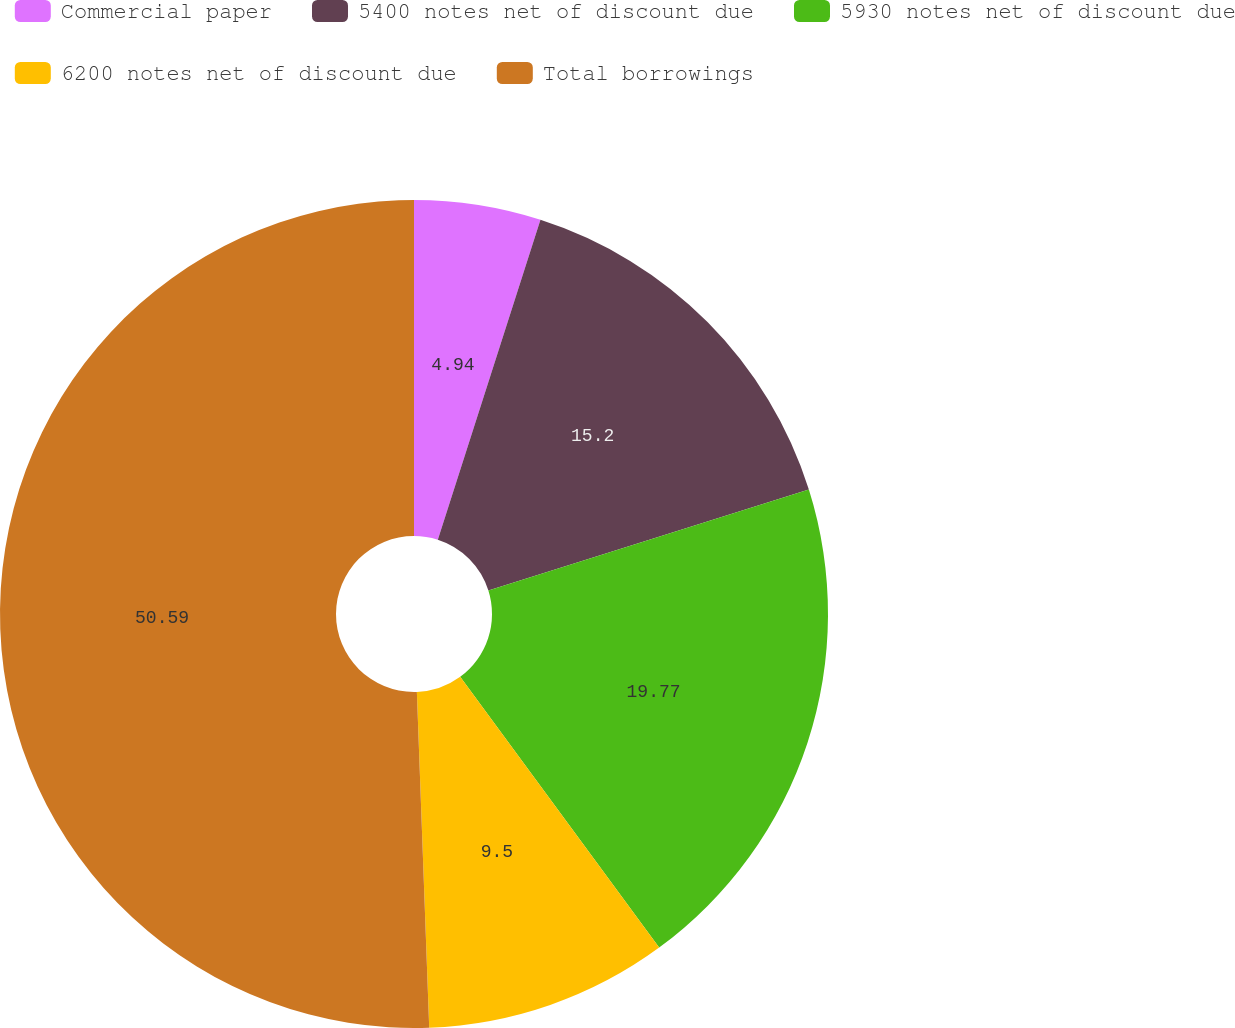Convert chart to OTSL. <chart><loc_0><loc_0><loc_500><loc_500><pie_chart><fcel>Commercial paper<fcel>5400 notes net of discount due<fcel>5930 notes net of discount due<fcel>6200 notes net of discount due<fcel>Total borrowings<nl><fcel>4.94%<fcel>15.2%<fcel>19.77%<fcel>9.5%<fcel>50.58%<nl></chart> 